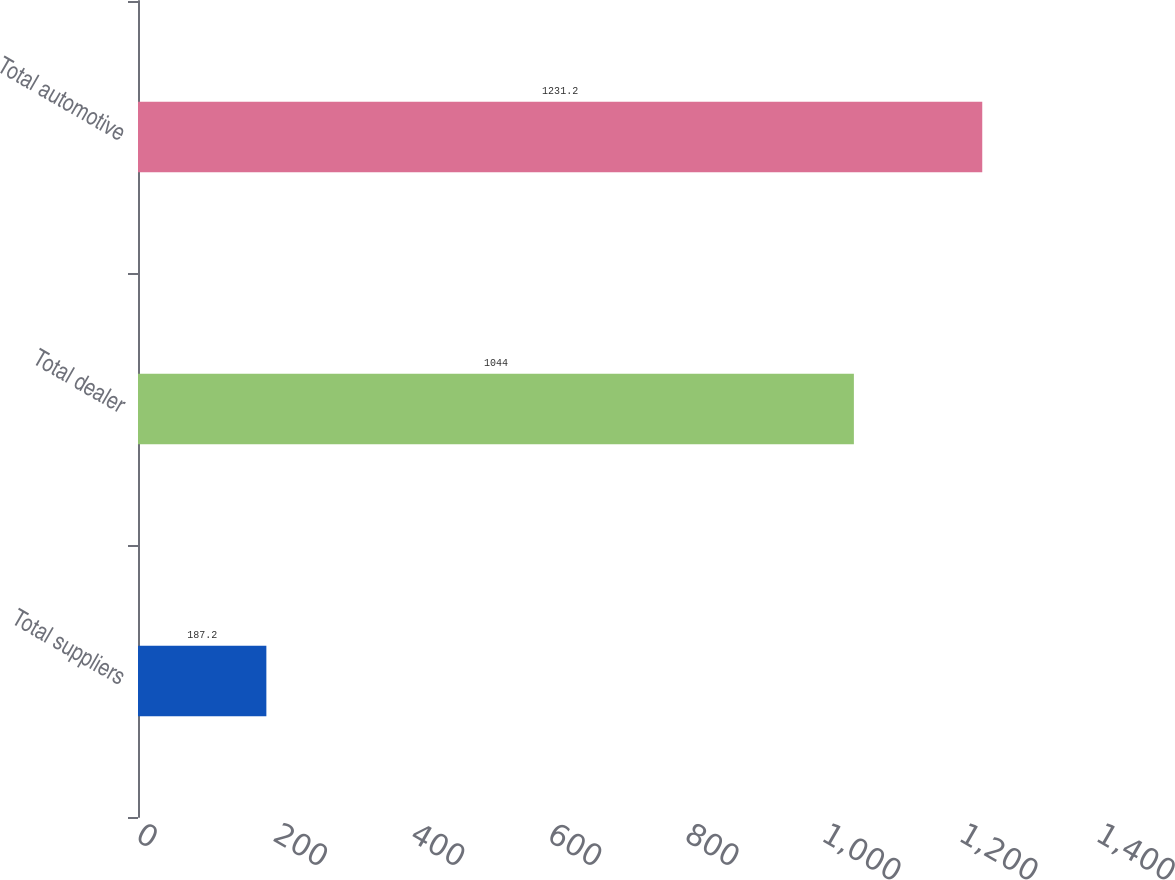Convert chart to OTSL. <chart><loc_0><loc_0><loc_500><loc_500><bar_chart><fcel>Total suppliers<fcel>Total dealer<fcel>Total automotive<nl><fcel>187.2<fcel>1044<fcel>1231.2<nl></chart> 